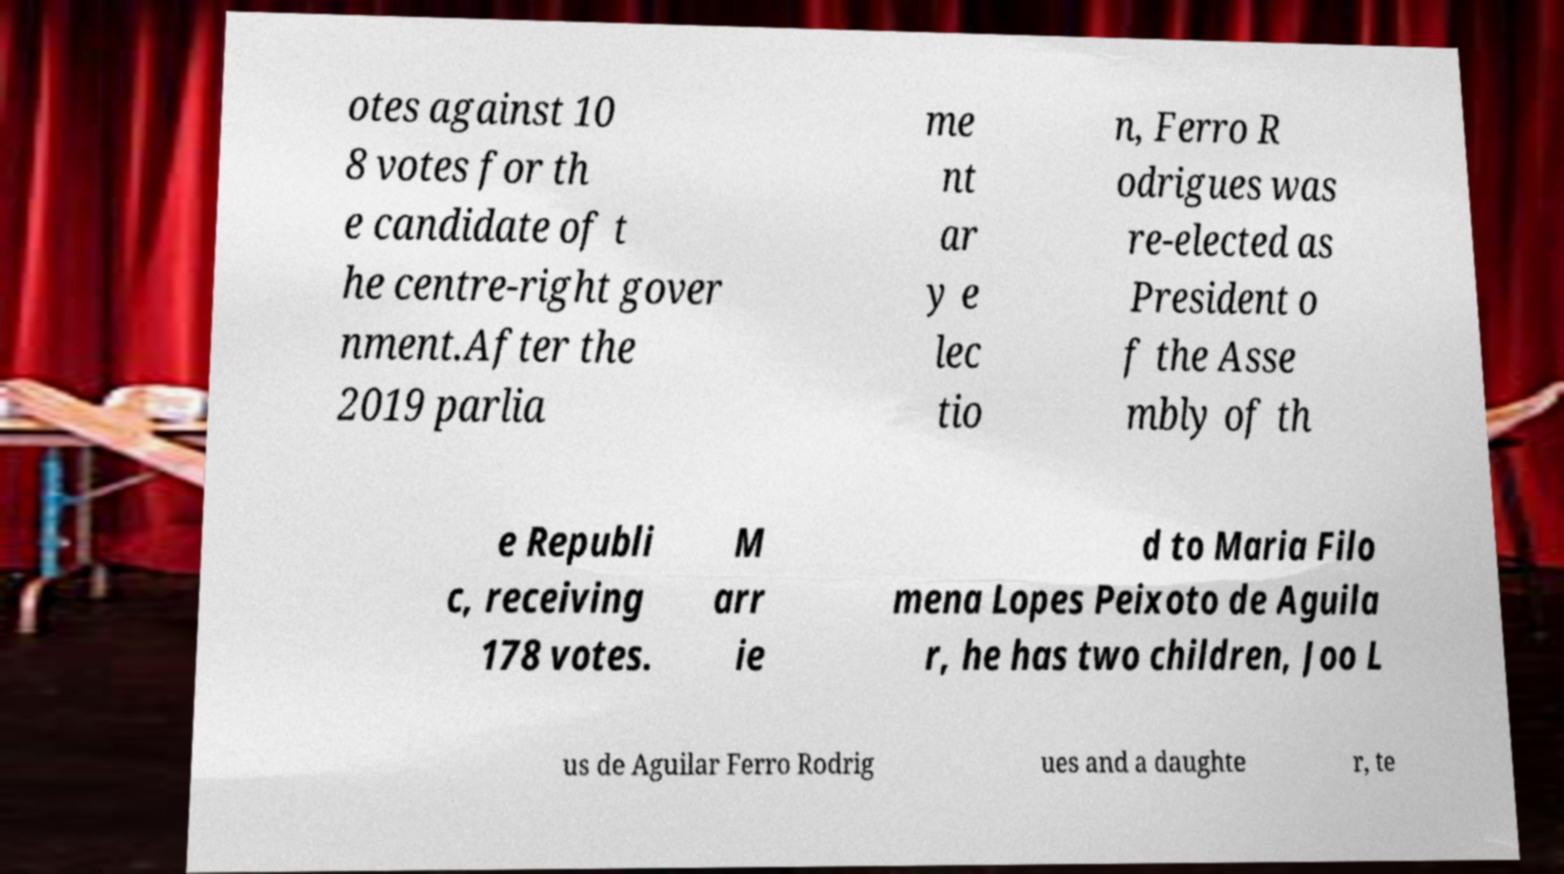Could you extract and type out the text from this image? otes against 10 8 votes for th e candidate of t he centre-right gover nment.After the 2019 parlia me nt ar y e lec tio n, Ferro R odrigues was re-elected as President o f the Asse mbly of th e Republi c, receiving 178 votes. M arr ie d to Maria Filo mena Lopes Peixoto de Aguila r, he has two children, Joo L us de Aguilar Ferro Rodrig ues and a daughte r, te 